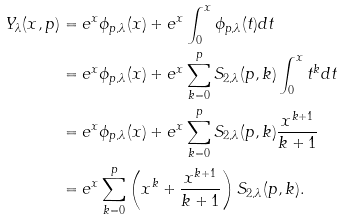Convert formula to latex. <formula><loc_0><loc_0><loc_500><loc_500>Y _ { \lambda } ( x , p ) & = e ^ { x } \phi _ { p , \lambda } ( x ) + e ^ { x } \int _ { 0 } ^ { x } \phi _ { p , \lambda } ( t ) d t \\ & = e ^ { x } \phi _ { p , \lambda } ( x ) + e ^ { x } \sum _ { k = 0 } ^ { p } S _ { 2 , \lambda } ( p , k ) \int _ { 0 } ^ { x } t ^ { k } d t \\ & = e ^ { x } \phi _ { p , \lambda } ( x ) + e ^ { x } \sum _ { k = 0 } ^ { p } S _ { 2 , \lambda } ( p , k ) \frac { x ^ { k + 1 } } { k + 1 } \\ & = e ^ { x } \sum _ { k = 0 } ^ { p } \left ( x { ^ { k } } + \frac { x ^ { k + 1 } } { k + 1 } \right ) S _ { 2 , \lambda } ( p , k ) .</formula> 